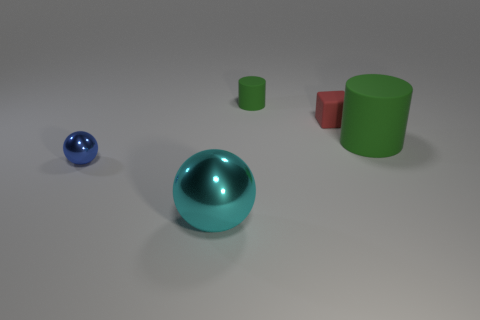Add 5 large cyan metallic things. How many objects exist? 10 Subtract all balls. How many objects are left? 3 Add 1 large objects. How many large objects exist? 3 Subtract 0 yellow cylinders. How many objects are left? 5 Subtract all big blue objects. Subtract all big metallic objects. How many objects are left? 4 Add 2 shiny spheres. How many shiny spheres are left? 4 